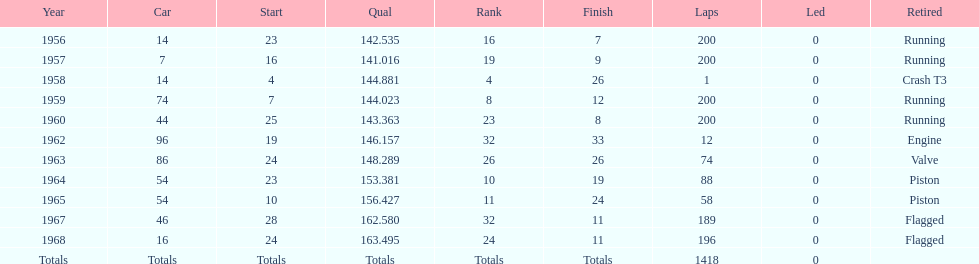What was the ultimate year it concluded the race? 1968. 